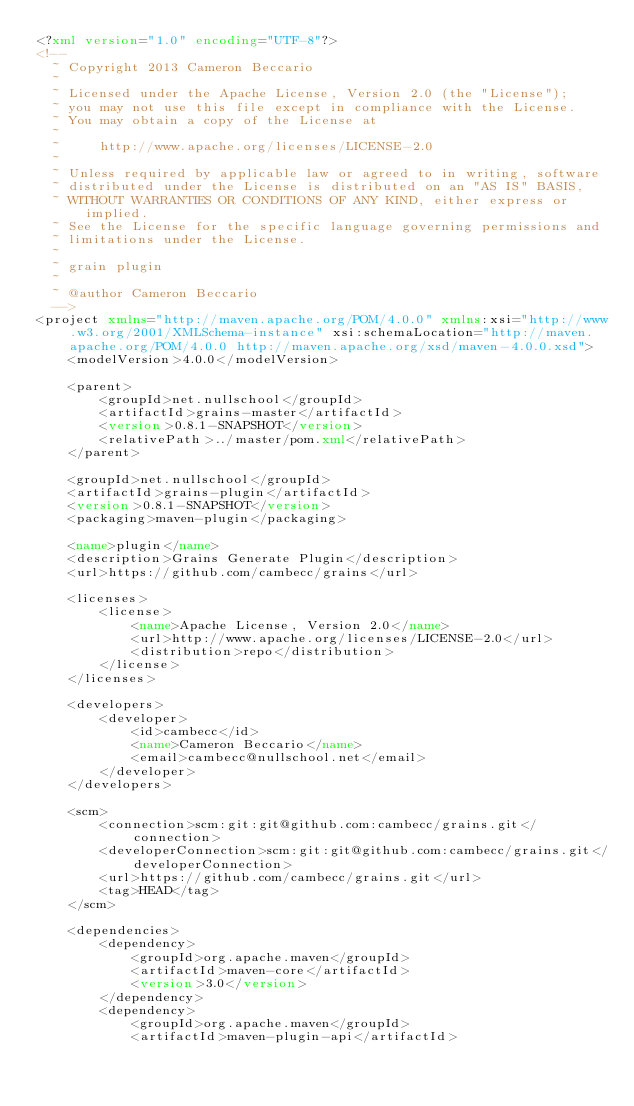Convert code to text. <code><loc_0><loc_0><loc_500><loc_500><_XML_><?xml version="1.0" encoding="UTF-8"?>
<!--
  ~ Copyright 2013 Cameron Beccario
  ~
  ~ Licensed under the Apache License, Version 2.0 (the "License");
  ~ you may not use this file except in compliance with the License.
  ~ You may obtain a copy of the License at
  ~
  ~     http://www.apache.org/licenses/LICENSE-2.0
  ~
  ~ Unless required by applicable law or agreed to in writing, software
  ~ distributed under the License is distributed on an "AS IS" BASIS,
  ~ WITHOUT WARRANTIES OR CONDITIONS OF ANY KIND, either express or implied.
  ~ See the License for the specific language governing permissions and
  ~ limitations under the License.
  ~
  ~ grain plugin
  ~
  ~ @author Cameron Beccario
  -->
<project xmlns="http://maven.apache.org/POM/4.0.0" xmlns:xsi="http://www.w3.org/2001/XMLSchema-instance" xsi:schemaLocation="http://maven.apache.org/POM/4.0.0 http://maven.apache.org/xsd/maven-4.0.0.xsd">
    <modelVersion>4.0.0</modelVersion>

    <parent>
        <groupId>net.nullschool</groupId>
        <artifactId>grains-master</artifactId>
        <version>0.8.1-SNAPSHOT</version>
        <relativePath>../master/pom.xml</relativePath>
    </parent>

    <groupId>net.nullschool</groupId>
    <artifactId>grains-plugin</artifactId>
    <version>0.8.1-SNAPSHOT</version>
    <packaging>maven-plugin</packaging>

    <name>plugin</name>
    <description>Grains Generate Plugin</description>
    <url>https://github.com/cambecc/grains</url>

    <licenses>
        <license>
            <name>Apache License, Version 2.0</name>
            <url>http://www.apache.org/licenses/LICENSE-2.0</url>
            <distribution>repo</distribution>
        </license>
    </licenses>

    <developers>
        <developer>
            <id>cambecc</id>
            <name>Cameron Beccario</name>
            <email>cambecc@nullschool.net</email>
        </developer>
    </developers>

    <scm>
        <connection>scm:git:git@github.com:cambecc/grains.git</connection>
        <developerConnection>scm:git:git@github.com:cambecc/grains.git</developerConnection>
        <url>https://github.com/cambecc/grains.git</url>
        <tag>HEAD</tag>
    </scm>

    <dependencies>
        <dependency>
            <groupId>org.apache.maven</groupId>
            <artifactId>maven-core</artifactId>
            <version>3.0</version>
        </dependency>
        <dependency>
            <groupId>org.apache.maven</groupId>
            <artifactId>maven-plugin-api</artifactId></code> 